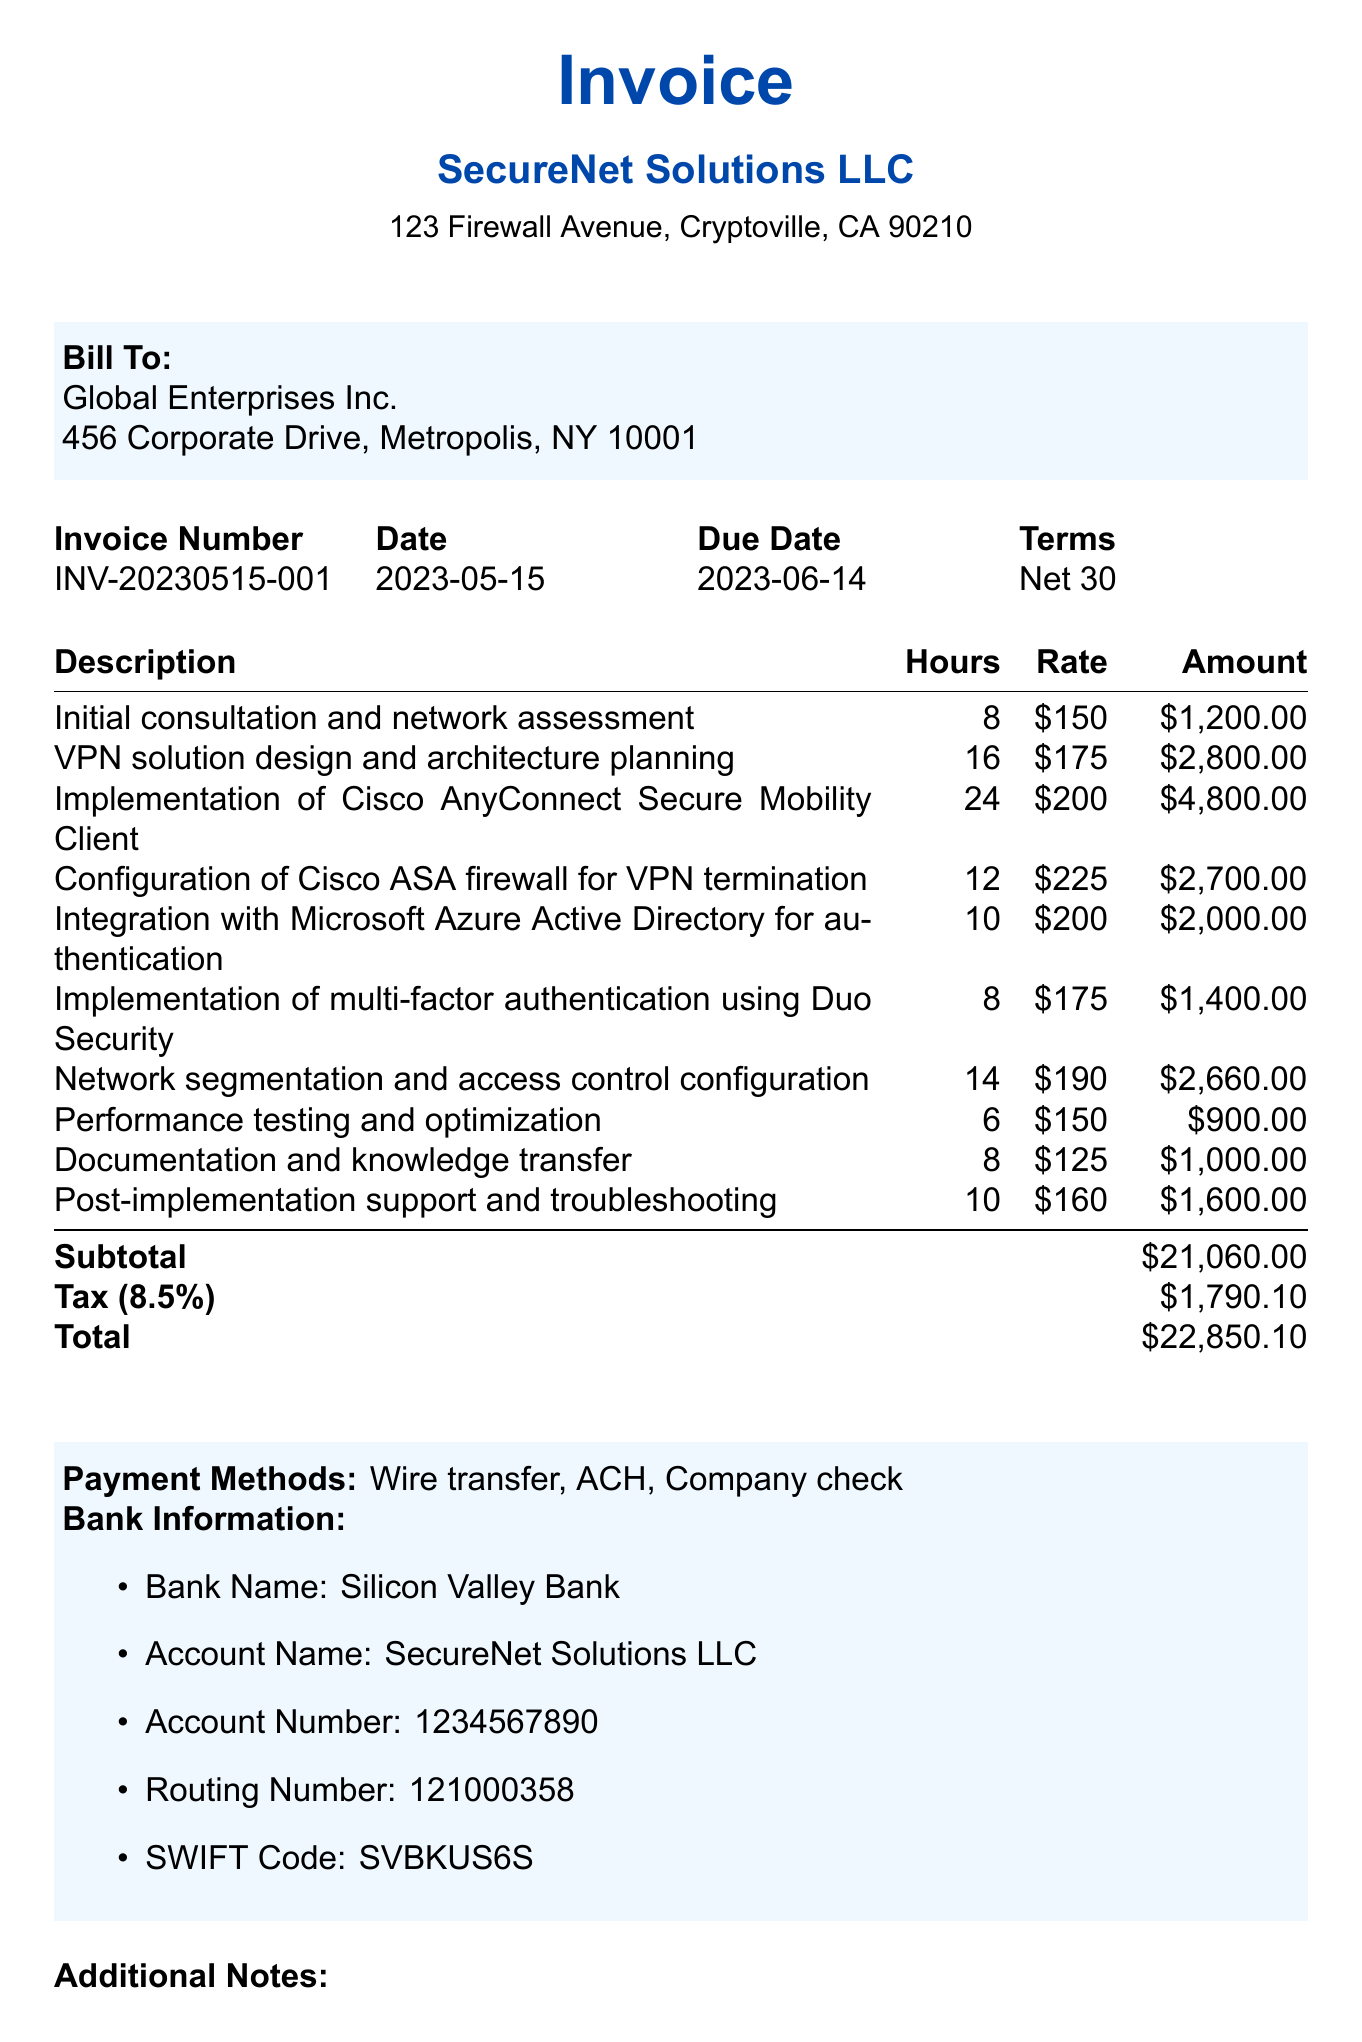What is the invoice number? The invoice number is listed clearly in the document for reference, which is essential for tracking the invoice.
Answer: INV-20230515-001 What is the due date for the invoice? The due date is specified in the document, indicating when payment should be made.
Answer: 2023-06-14 How much is the subtotal? The subtotal is a key financial figure reflecting the total of services without tax, found in the main table.
Answer: $21,060.00 What is the tax rate applied? The tax rate is mentioned in the document, which is necessary for calculating the total amount due.
Answer: 8.5% What service had the highest charge? The highest charge is found by comparing the amounts for each service listed in the table.
Answer: Implementation of Cisco AnyConnect Secure Mobility Client What payment methods are accepted? The document lists accepted payment methods, which provides clients with options for payment.
Answer: Wire transfer, ACH, Company check How many hours were spent on network segmentation and access control configuration? This detail is found in the service list, indicating the time allocated to a specific task.
Answer: 14 What is the total amount due? The total amount due is an essential figure for clients to know the complete financial obligation.
Answer: $22,850.10 What is the company address of SecureNet Solutions LLC? The company address is included in the invoice, important for official correspondence and payment processing.
Answer: 123 Firewall Avenue, Cryptoville, CA 90210 